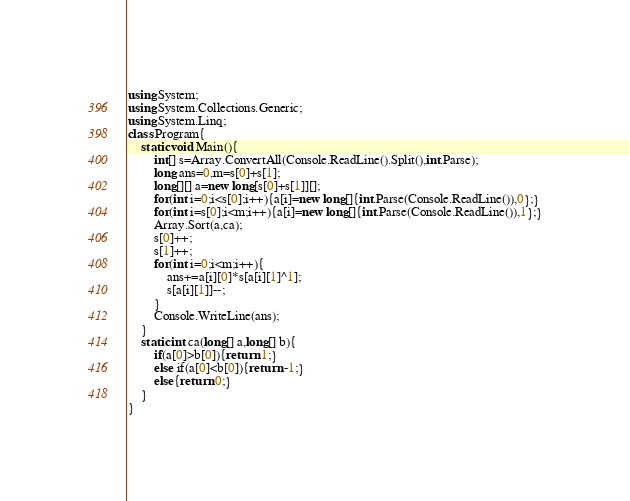Convert code to text. <code><loc_0><loc_0><loc_500><loc_500><_C#_>using System;
using System.Collections.Generic;
using System.Linq;
class Program{
	static void Main(){
		int[] s=Array.ConvertAll(Console.ReadLine().Split(),int.Parse);
		long ans=0,m=s[0]+s[1];
		long[][] a=new long[s[0]+s[1]][];
		for(int i=0;i<s[0];i++){a[i]=new long[]{int.Parse(Console.ReadLine()),0};}
		for(int i=s[0];i<m;i++){a[i]=new long[]{int.Parse(Console.ReadLine()),1};}
		Array.Sort(a,ca);
		s[0]++;
		s[1]++;
		for(int i=0;i<m;i++){
			ans+=a[i][0]*s[a[i][1]^1];
			s[a[i][1]]--;
		}
		Console.WriteLine(ans);
	}
	static int ca(long[] a,long[] b){
		if(a[0]>b[0]){return 1;}
		else if(a[0]<b[0]){return -1;}
		else{return 0;}
	}
}</code> 